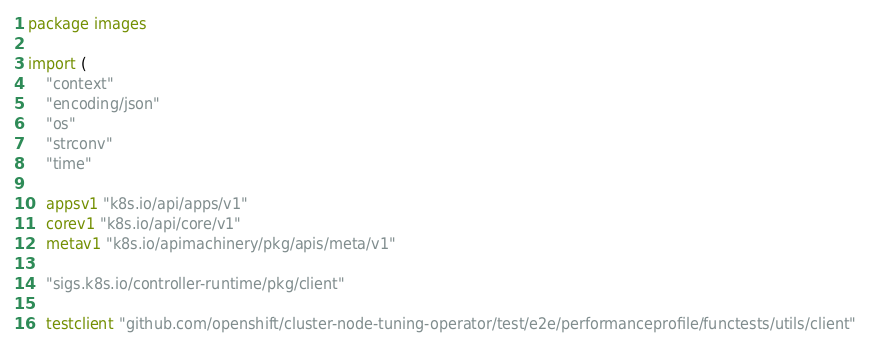<code> <loc_0><loc_0><loc_500><loc_500><_Go_>package images

import (
	"context"
	"encoding/json"
	"os"
	"strconv"
	"time"

	appsv1 "k8s.io/api/apps/v1"
	corev1 "k8s.io/api/core/v1"
	metav1 "k8s.io/apimachinery/pkg/apis/meta/v1"

	"sigs.k8s.io/controller-runtime/pkg/client"

	testclient "github.com/openshift/cluster-node-tuning-operator/test/e2e/performanceprofile/functests/utils/client"</code> 